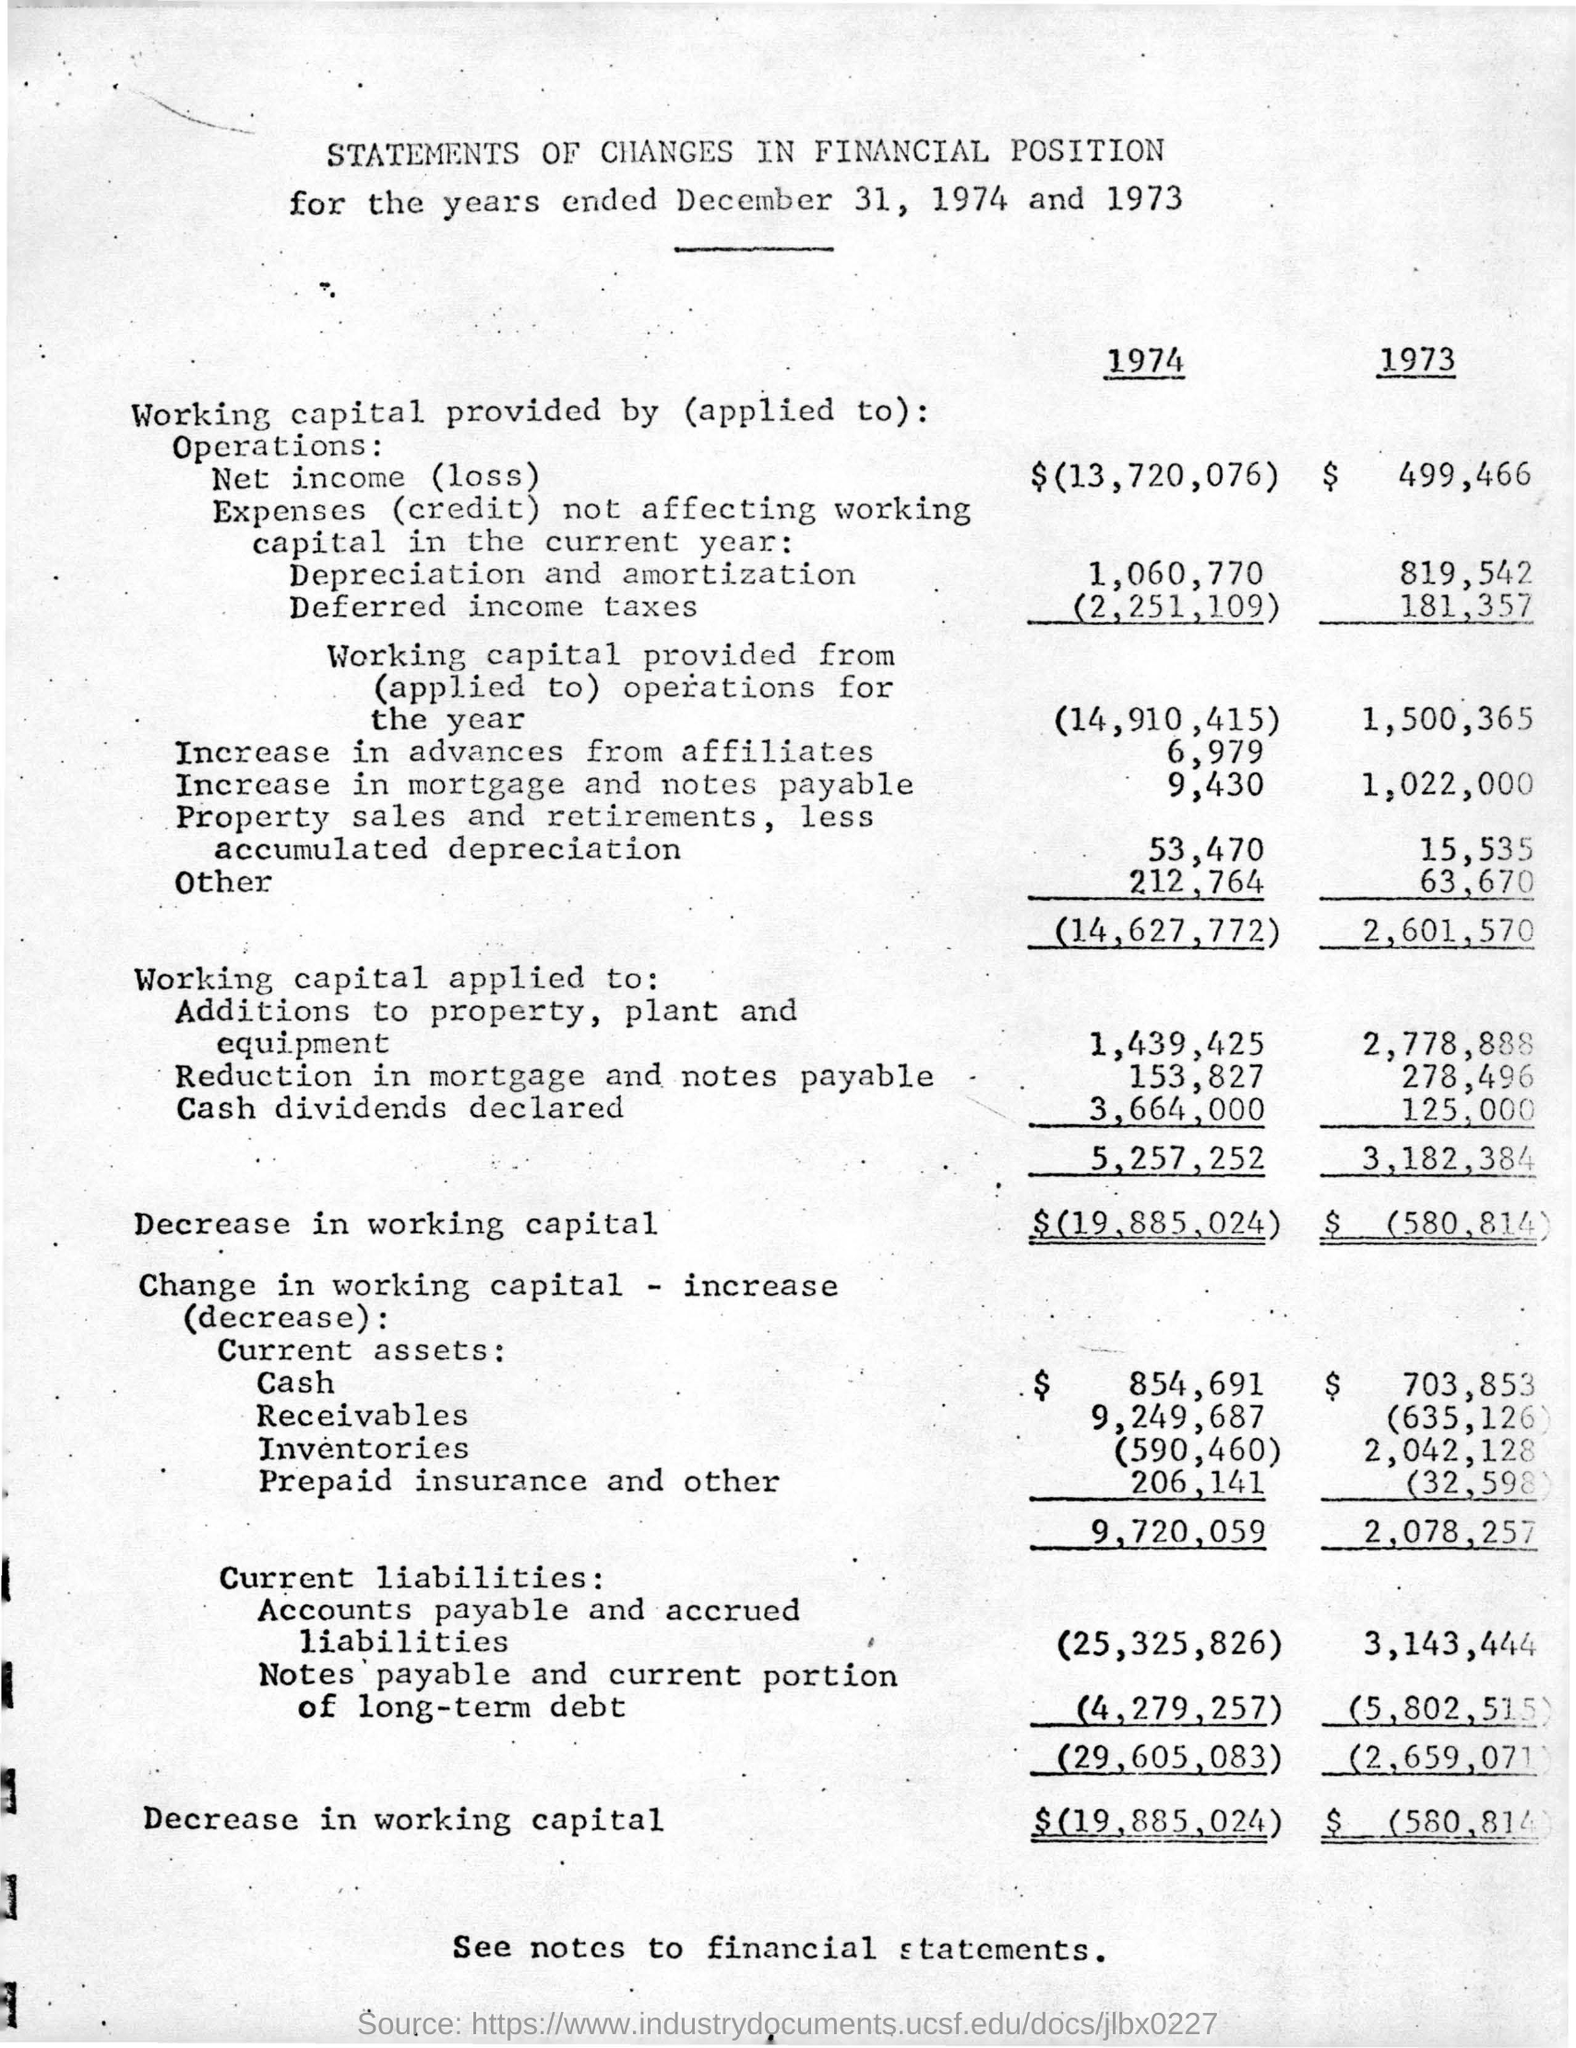Indicate a few pertinent items in this graphic. The cash dividends declared for the year 1974 were 3,664,000. On the date taken for the two years, December 31st, was taken. The decrease in working capital for the year 1974 was $19,885,024. 